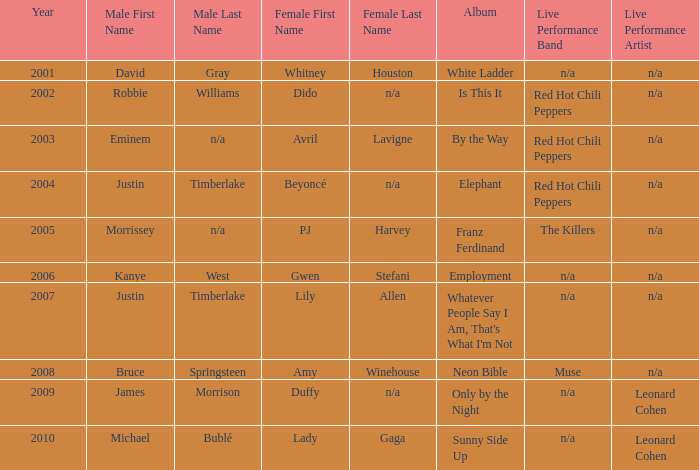Which female artist has an album named elephant? Beyoncé. 